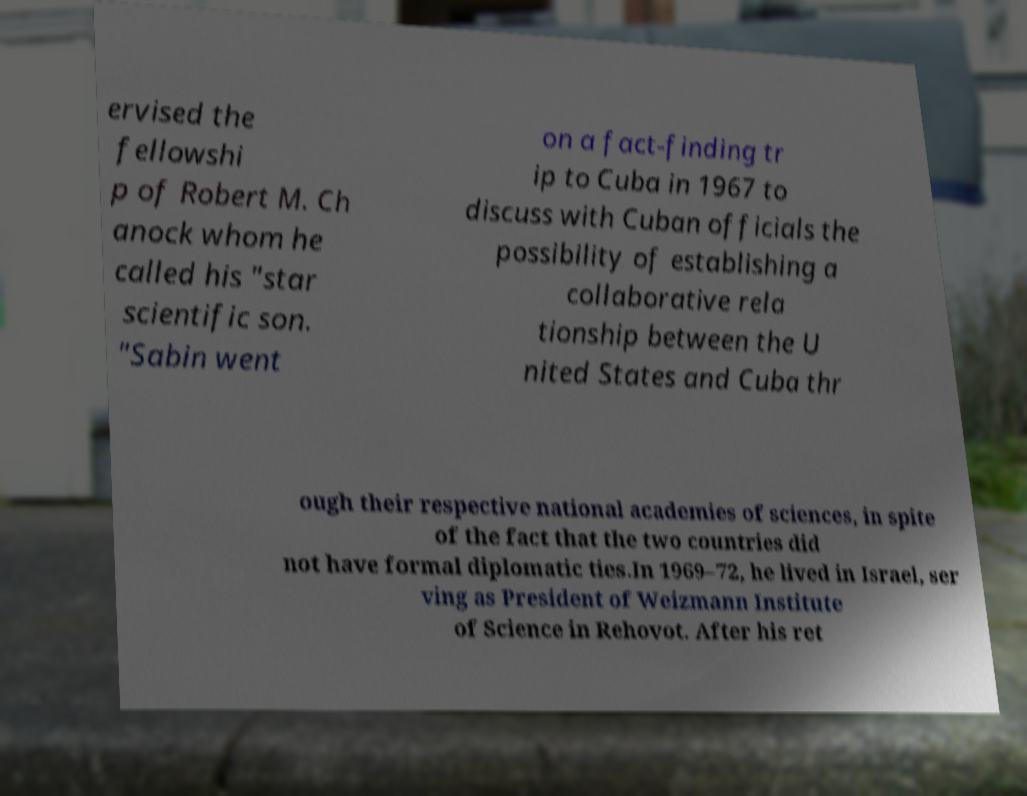There's text embedded in this image that I need extracted. Can you transcribe it verbatim? ervised the fellowshi p of Robert M. Ch anock whom he called his "star scientific son. "Sabin went on a fact-finding tr ip to Cuba in 1967 to discuss with Cuban officials the possibility of establishing a collaborative rela tionship between the U nited States and Cuba thr ough their respective national academies of sciences, in spite of the fact that the two countries did not have formal diplomatic ties.In 1969–72, he lived in Israel, ser ving as President of Weizmann Institute of Science in Rehovot. After his ret 